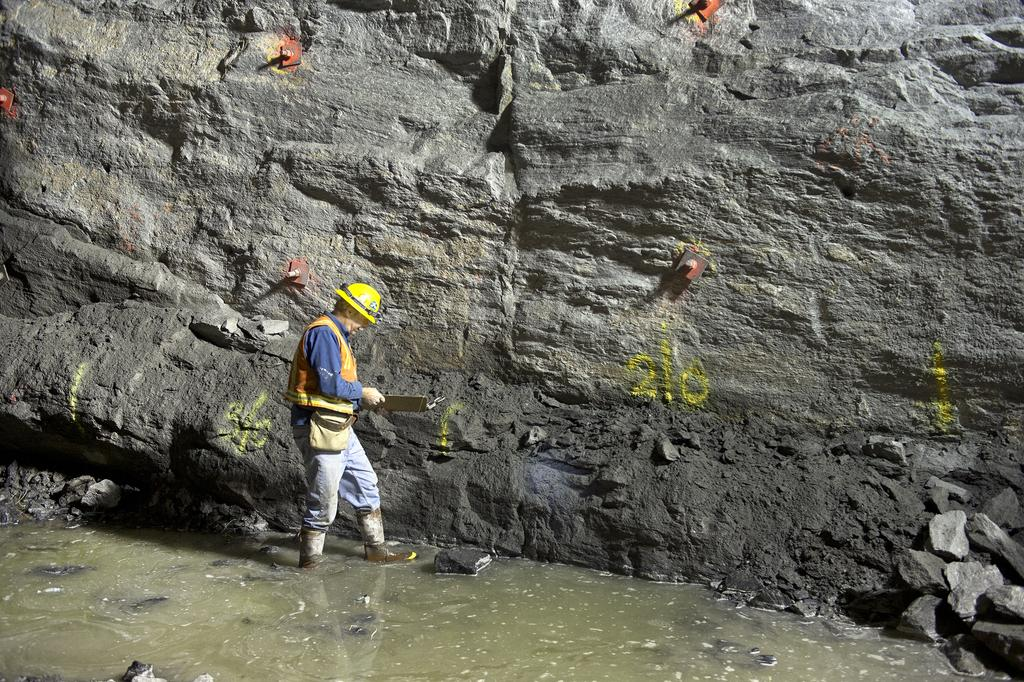Who is the main subject in the image? There is a person in the center of the image. What protective gear is the person wearing? The person is wearing a helmet. What type of footwear is the person wearing? The person is wearing shoes. What can be seen in the background of the image? There is a rock in the background of the image. What is at the bottom of the image? There is water at the bottom of the image. What type of suit is the person wearing in the scene? The person is not wearing a suit in the image; they are wearing a helmet and shoes. What school is depicted in the background of the image? There is no school present in the image; it features a rock in the background. 